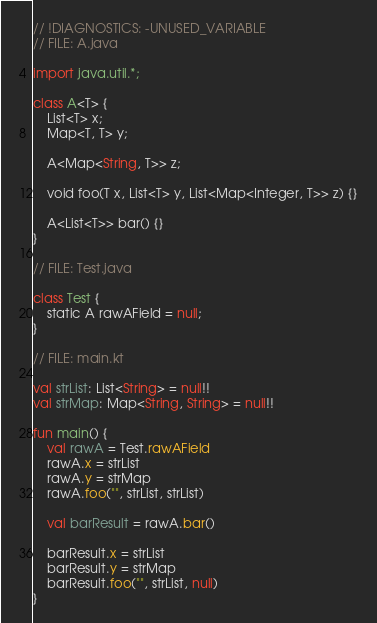<code> <loc_0><loc_0><loc_500><loc_500><_Kotlin_>// !DIAGNOSTICS: -UNUSED_VARIABLE
// FILE: A.java

import java.util.*;

class A<T> {
    List<T> x;
    Map<T, T> y;

    A<Map<String, T>> z;

    void foo(T x, List<T> y, List<Map<Integer, T>> z) {}

    A<List<T>> bar() {}
}

// FILE: Test.java

class Test {
    static A rawAField = null;
}

// FILE: main.kt

val strList: List<String> = null!!
val strMap: Map<String, String> = null!!

fun main() {
    val rawA = Test.rawAField
    rawA.x = strList
    rawA.y = strMap
    rawA.foo("", strList, strList)

    val barResult = rawA.bar()

    barResult.x = strList
    barResult.y = strMap
    barResult.foo("", strList, null)
}
</code> 